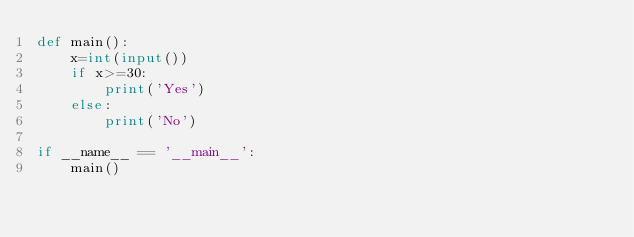<code> <loc_0><loc_0><loc_500><loc_500><_Python_>def main():
    x=int(input())
    if x>=30:
        print('Yes')
    else:
        print('No')

if __name__ == '__main__':
    main()</code> 